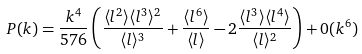<formula> <loc_0><loc_0><loc_500><loc_500>P ( k ) = \frac { k ^ { 4 } } { 5 7 6 } \left ( \frac { \langle l ^ { 2 } \rangle \langle l ^ { 3 } \rangle ^ { 2 } } { \langle l \rangle ^ { 3 } } + \frac { \langle l ^ { 6 } \rangle } { \langle l \rangle } - 2 \frac { \langle l ^ { 3 } \rangle \langle l ^ { 4 } \rangle } { \langle l \rangle ^ { 2 } } \right ) + 0 ( k ^ { 6 } )</formula> 